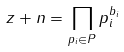Convert formula to latex. <formula><loc_0><loc_0><loc_500><loc_500>z + n = \prod _ { p _ { i } \in P } p _ { i } ^ { b _ { i } }</formula> 